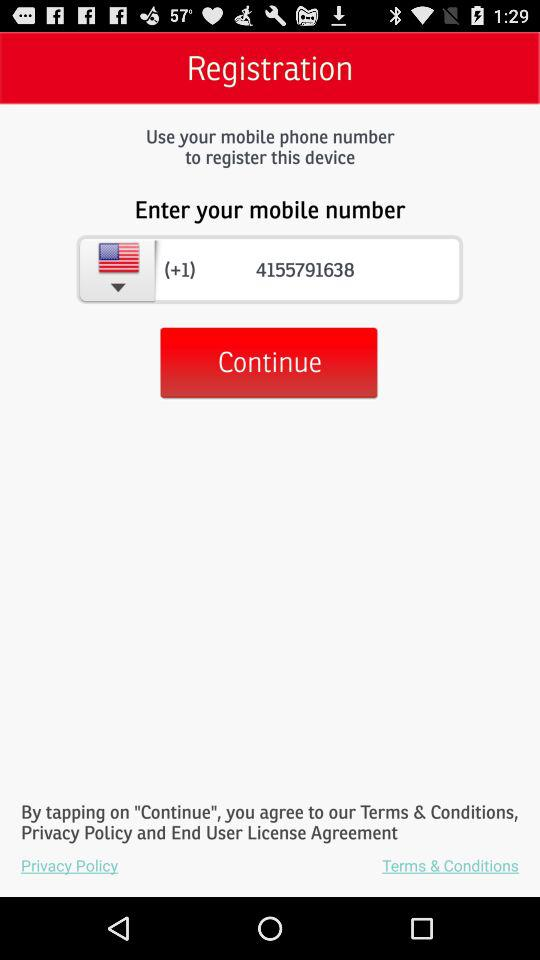What is the mobile number? The mobile number displayed in the registration page of the device setup shown in the image is (+1) 4155791638. 